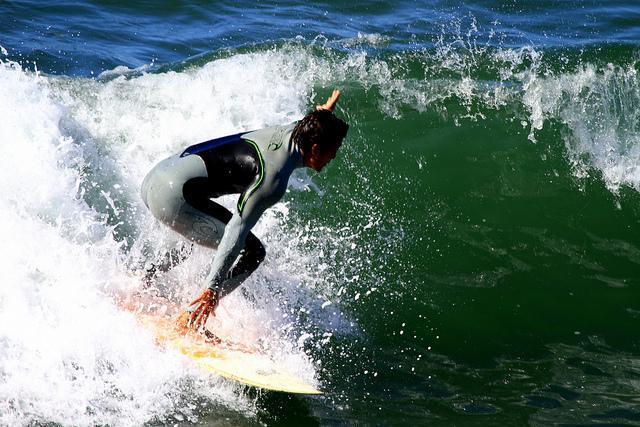How many surfboards are visible?
Give a very brief answer. 1. How many elephants are lying down?
Give a very brief answer. 0. 